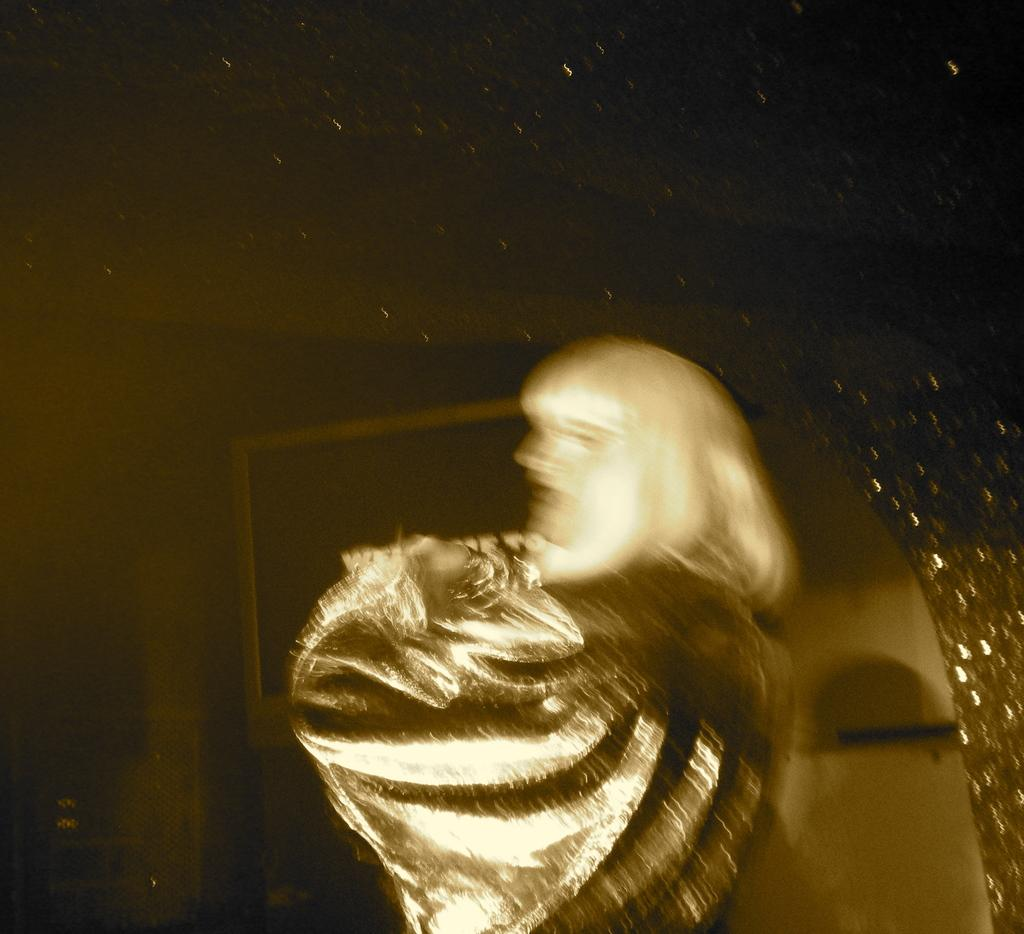Who is the main subject in the image? There is a woman in the image. Where is the woman located in the image? The woman is in the front of the image. What can be seen behind the woman in the image? There are objects in the background of the image. What month is depicted in the image? There is no specific month depicted in the image; it is a still image of a woman and objects in the background. How many nests can be seen in the image? There are no nests present in the image. 